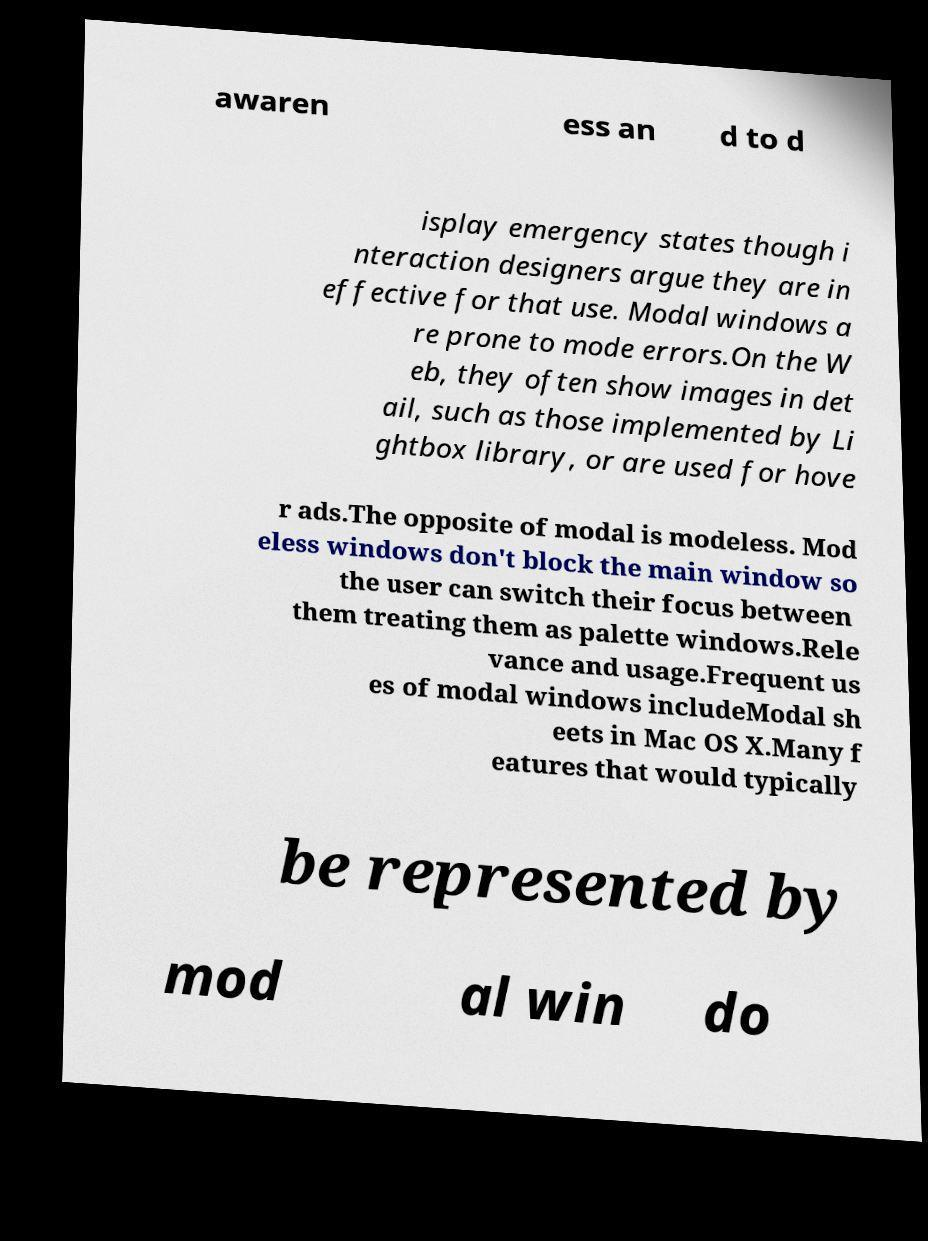I need the written content from this picture converted into text. Can you do that? awaren ess an d to d isplay emergency states though i nteraction designers argue they are in effective for that use. Modal windows a re prone to mode errors.On the W eb, they often show images in det ail, such as those implemented by Li ghtbox library, or are used for hove r ads.The opposite of modal is modeless. Mod eless windows don't block the main window so the user can switch their focus between them treating them as palette windows.Rele vance and usage.Frequent us es of modal windows includeModal sh eets in Mac OS X.Many f eatures that would typically be represented by mod al win do 